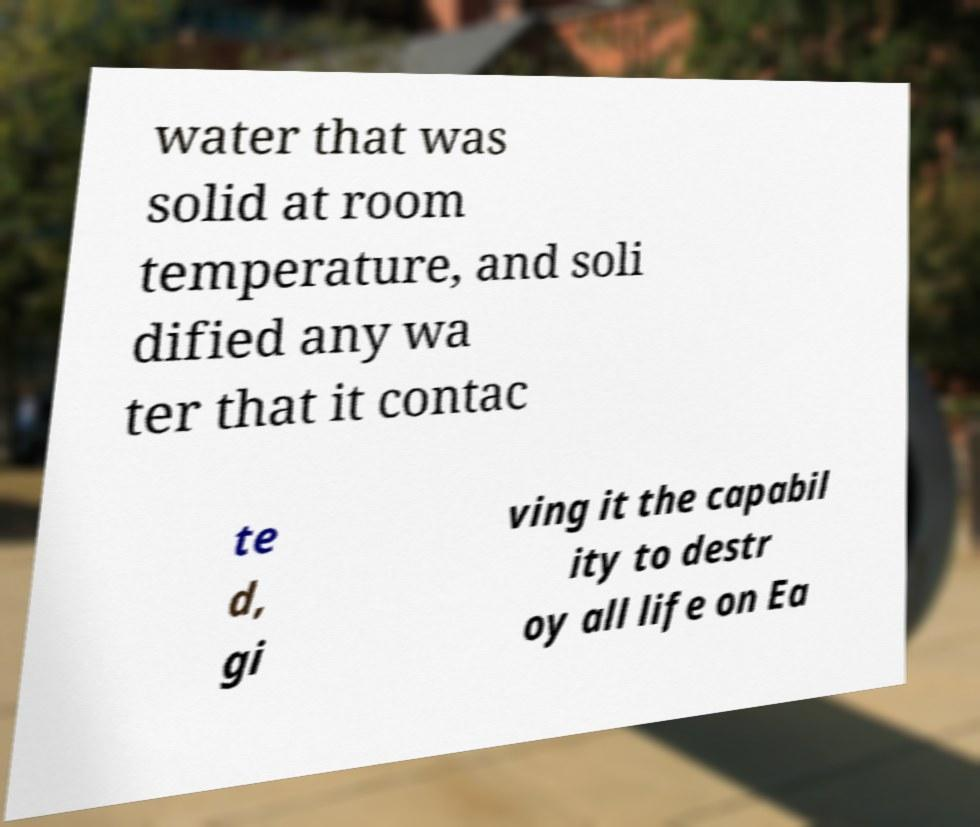Could you assist in decoding the text presented in this image and type it out clearly? water that was solid at room temperature, and soli dified any wa ter that it contac te d, gi ving it the capabil ity to destr oy all life on Ea 